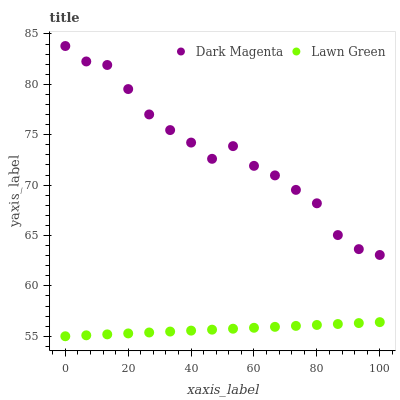Does Lawn Green have the minimum area under the curve?
Answer yes or no. Yes. Does Dark Magenta have the maximum area under the curve?
Answer yes or no. Yes. Does Dark Magenta have the minimum area under the curve?
Answer yes or no. No. Is Lawn Green the smoothest?
Answer yes or no. Yes. Is Dark Magenta the roughest?
Answer yes or no. Yes. Is Dark Magenta the smoothest?
Answer yes or no. No. Does Lawn Green have the lowest value?
Answer yes or no. Yes. Does Dark Magenta have the lowest value?
Answer yes or no. No. Does Dark Magenta have the highest value?
Answer yes or no. Yes. Is Lawn Green less than Dark Magenta?
Answer yes or no. Yes. Is Dark Magenta greater than Lawn Green?
Answer yes or no. Yes. Does Lawn Green intersect Dark Magenta?
Answer yes or no. No. 